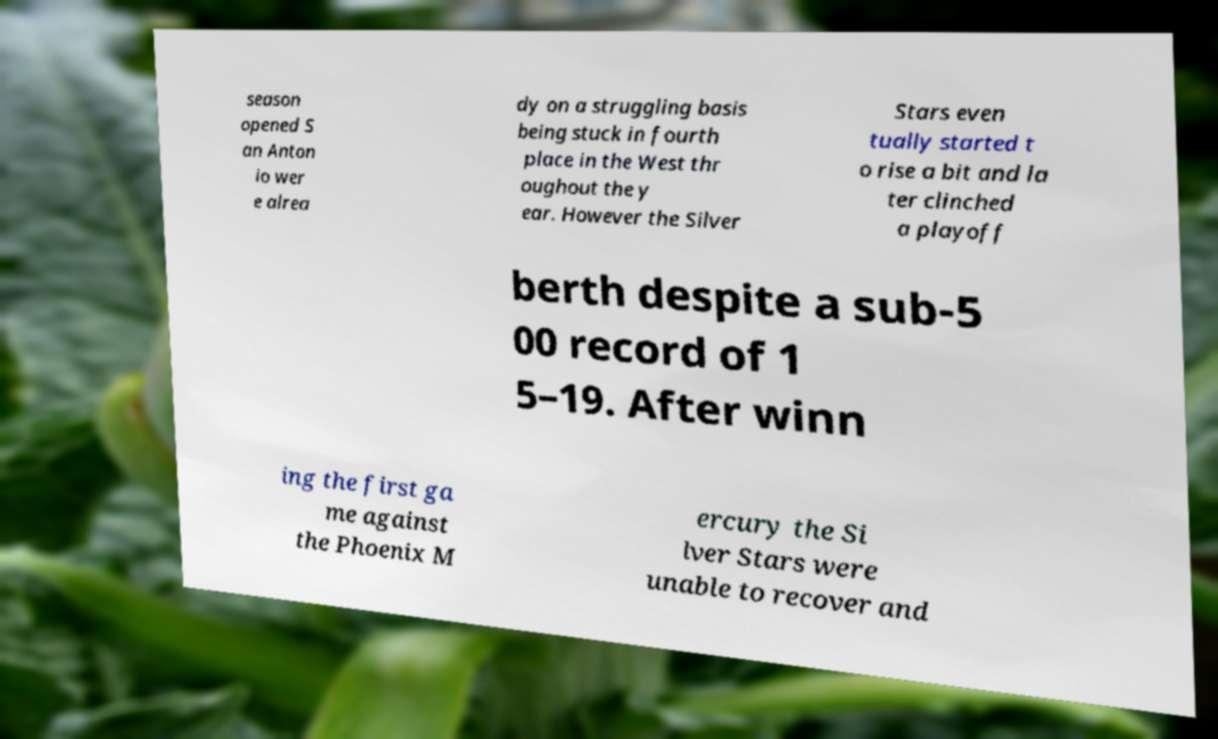There's text embedded in this image that I need extracted. Can you transcribe it verbatim? season opened S an Anton io wer e alrea dy on a struggling basis being stuck in fourth place in the West thr oughout the y ear. However the Silver Stars even tually started t o rise a bit and la ter clinched a playoff berth despite a sub-5 00 record of 1 5–19. After winn ing the first ga me against the Phoenix M ercury the Si lver Stars were unable to recover and 